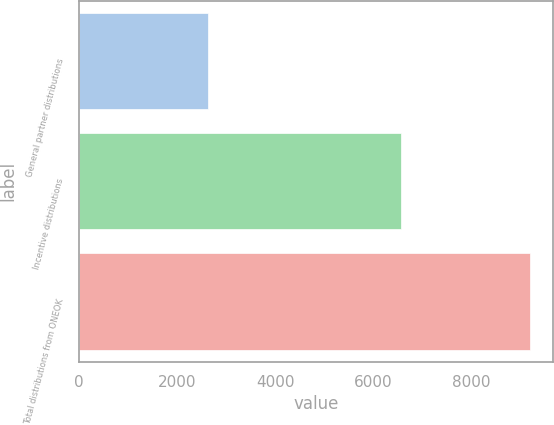Convert chart. <chart><loc_0><loc_0><loc_500><loc_500><bar_chart><fcel>General partner distributions<fcel>Incentive distributions<fcel>Total distributions from ONEOK<nl><fcel>2632<fcel>6568<fcel>9200<nl></chart> 